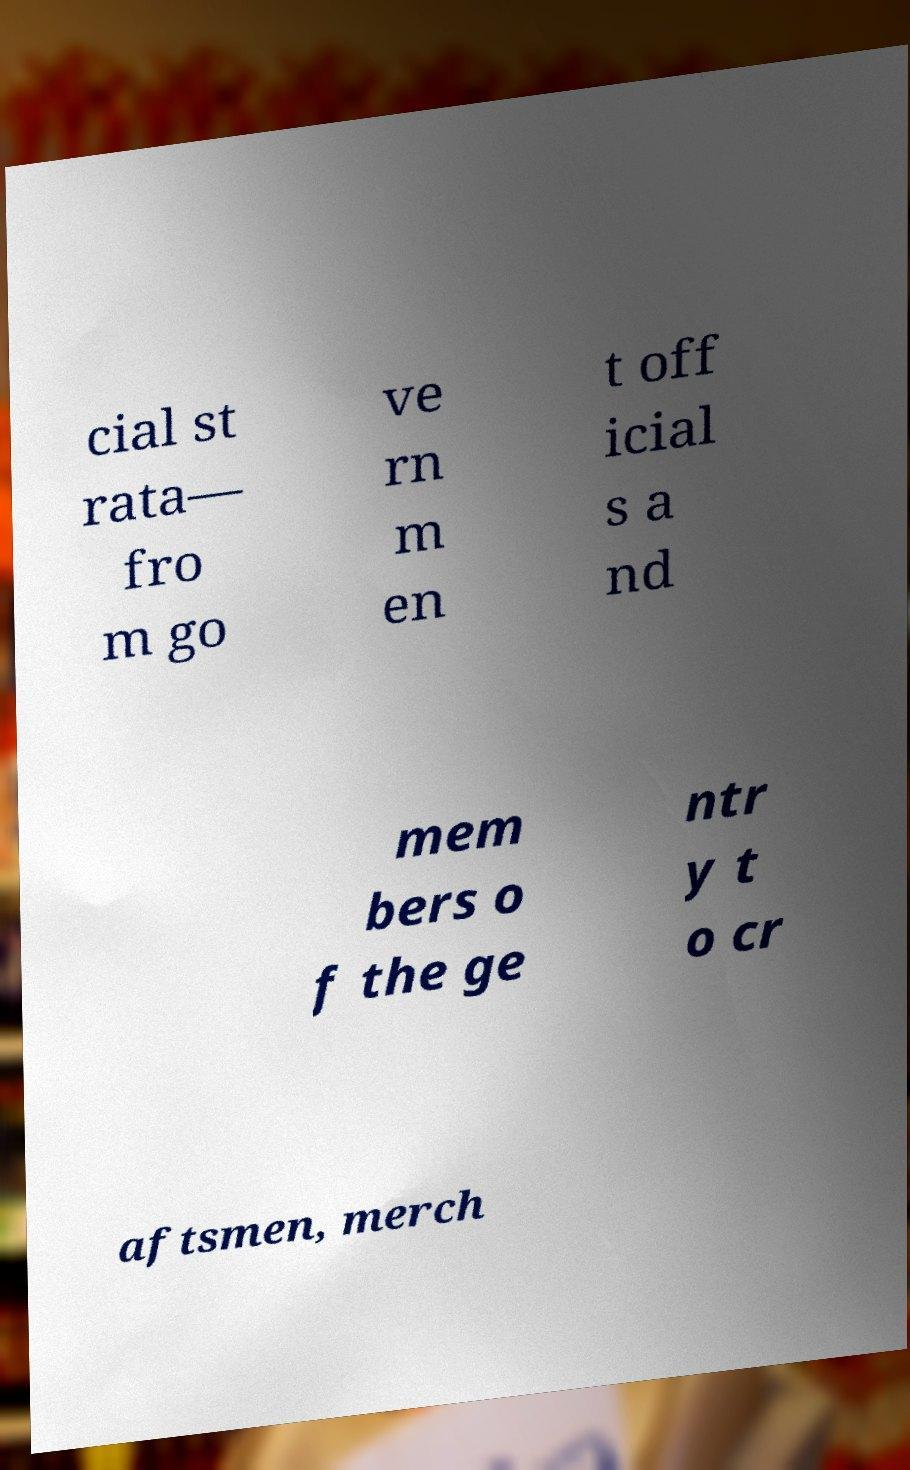Could you assist in decoding the text presented in this image and type it out clearly? cial st rata— fro m go ve rn m en t off icial s a nd mem bers o f the ge ntr y t o cr aftsmen, merch 